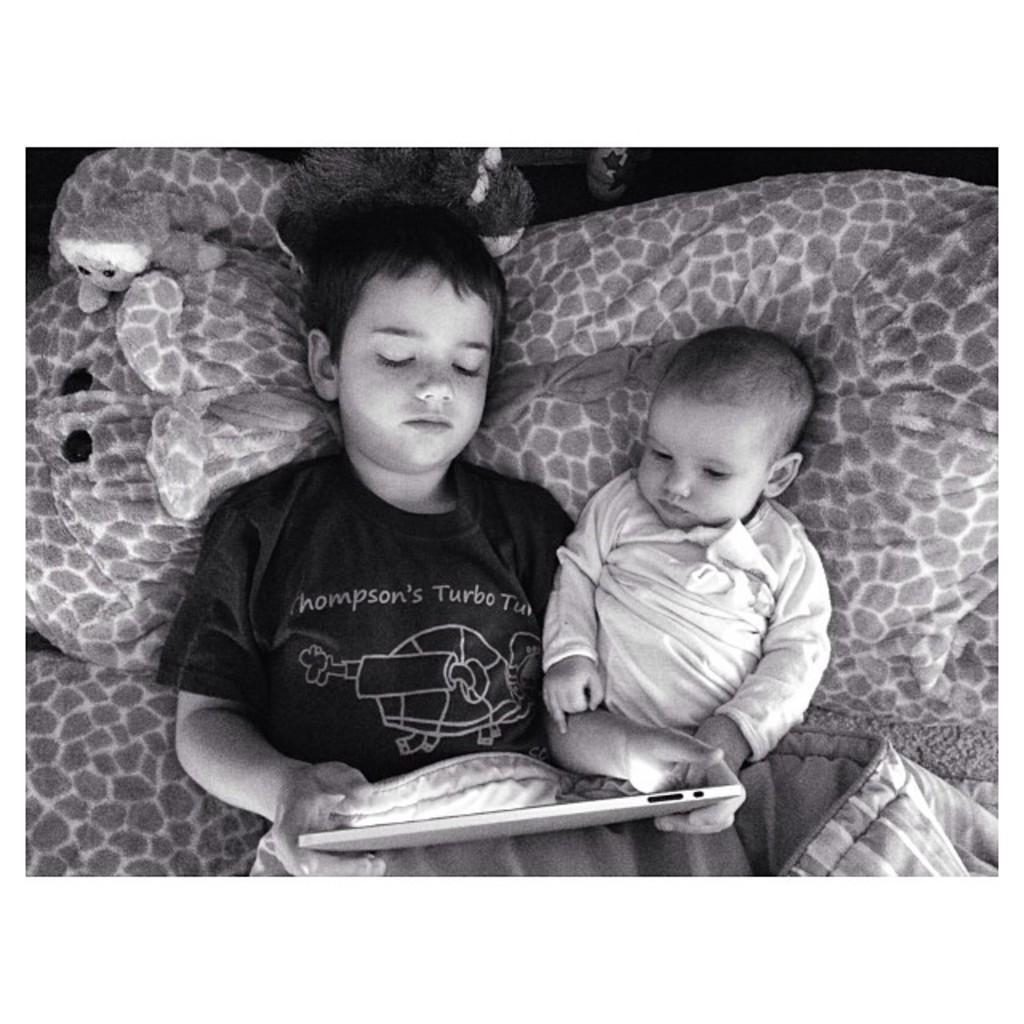In one or two sentences, can you explain what this image depicts? In this image there are two kids lying on the bed and one of them is holding an iPad, around the kids there are dolls. 